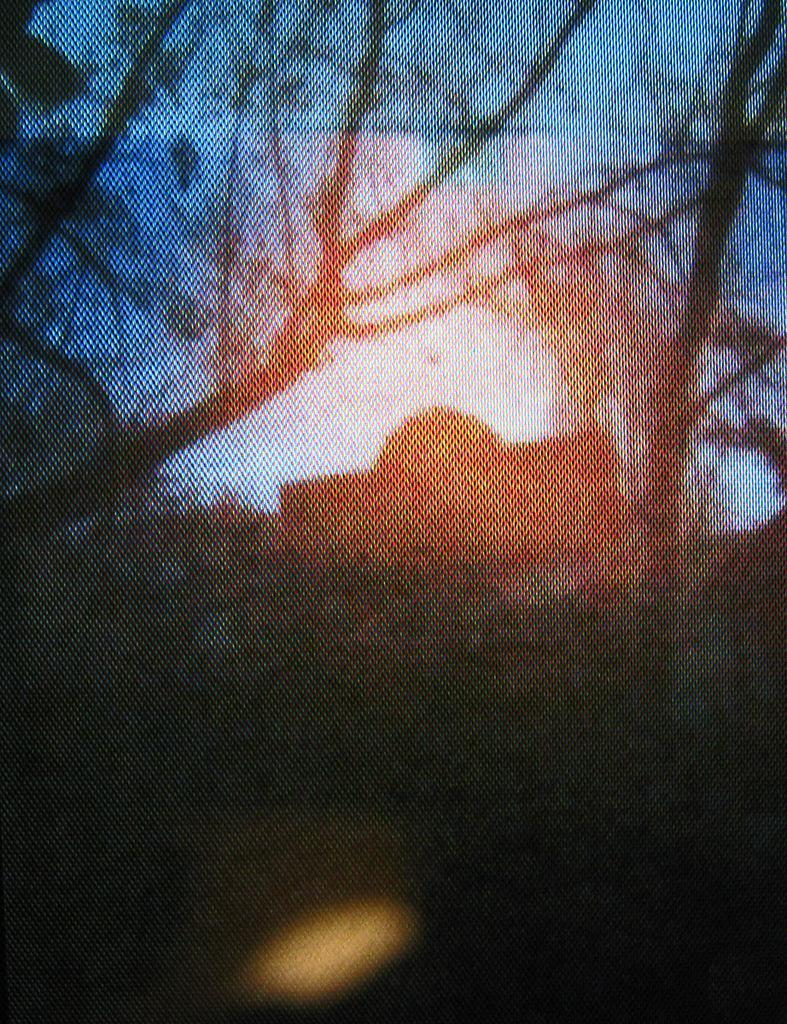What is the overall quality of the image? The image appears slightly blurred. What type of natural elements can be seen in the image? There are trees in the image. What type of man-made structure is present in the image? There is a building in the image. What part of the natural environment is visible in the image? The sky is visible in the image. How many brothers are visible in the image? There are no brothers present in the image. What type of insect can be seen flying in the sky in the image? There are no insects visible in the image; only trees, a building, and the sky are present. 